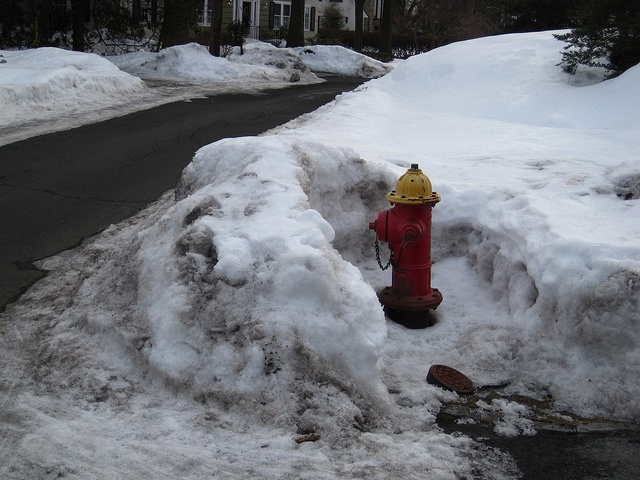Describe the objects in this image and their specific colors. I can see a fire hydrant in black, maroon, and olive tones in this image. 